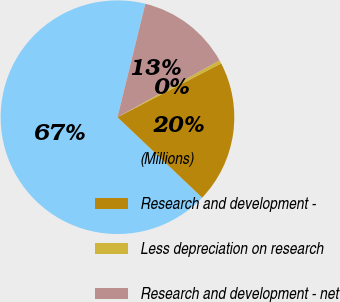<chart> <loc_0><loc_0><loc_500><loc_500><pie_chart><fcel>(Millions)<fcel>Research and development -<fcel>Less depreciation on research<fcel>Research and development - net<nl><fcel>66.74%<fcel>19.71%<fcel>0.46%<fcel>13.08%<nl></chart> 